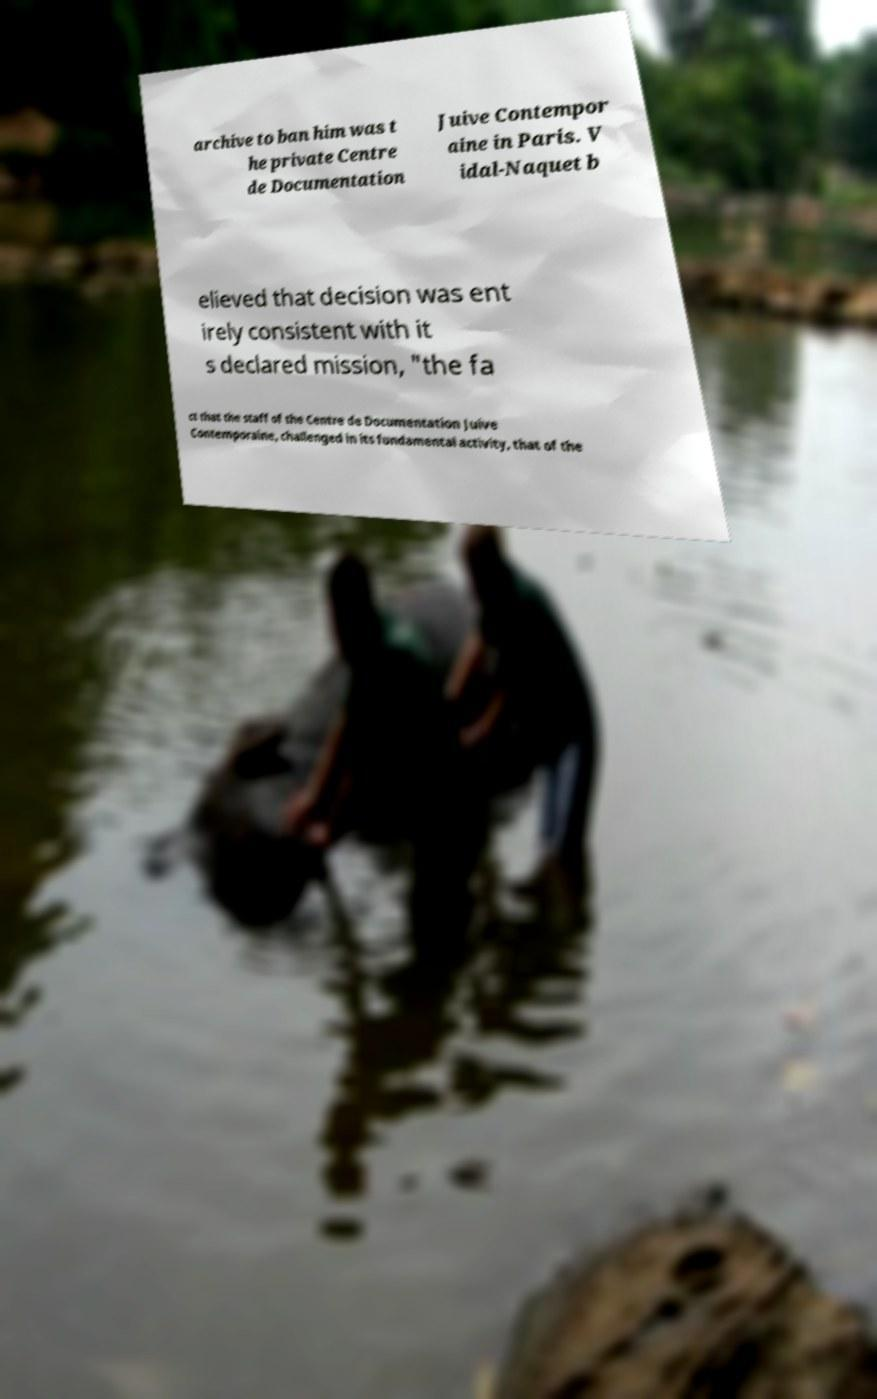I need the written content from this picture converted into text. Can you do that? archive to ban him was t he private Centre de Documentation Juive Contempor aine in Paris. V idal-Naquet b elieved that decision was ent irely consistent with it s declared mission, "the fa ct that the staff of the Centre de Documentation Juive Contemporaine, challenged in its fundamental activity, that of the 